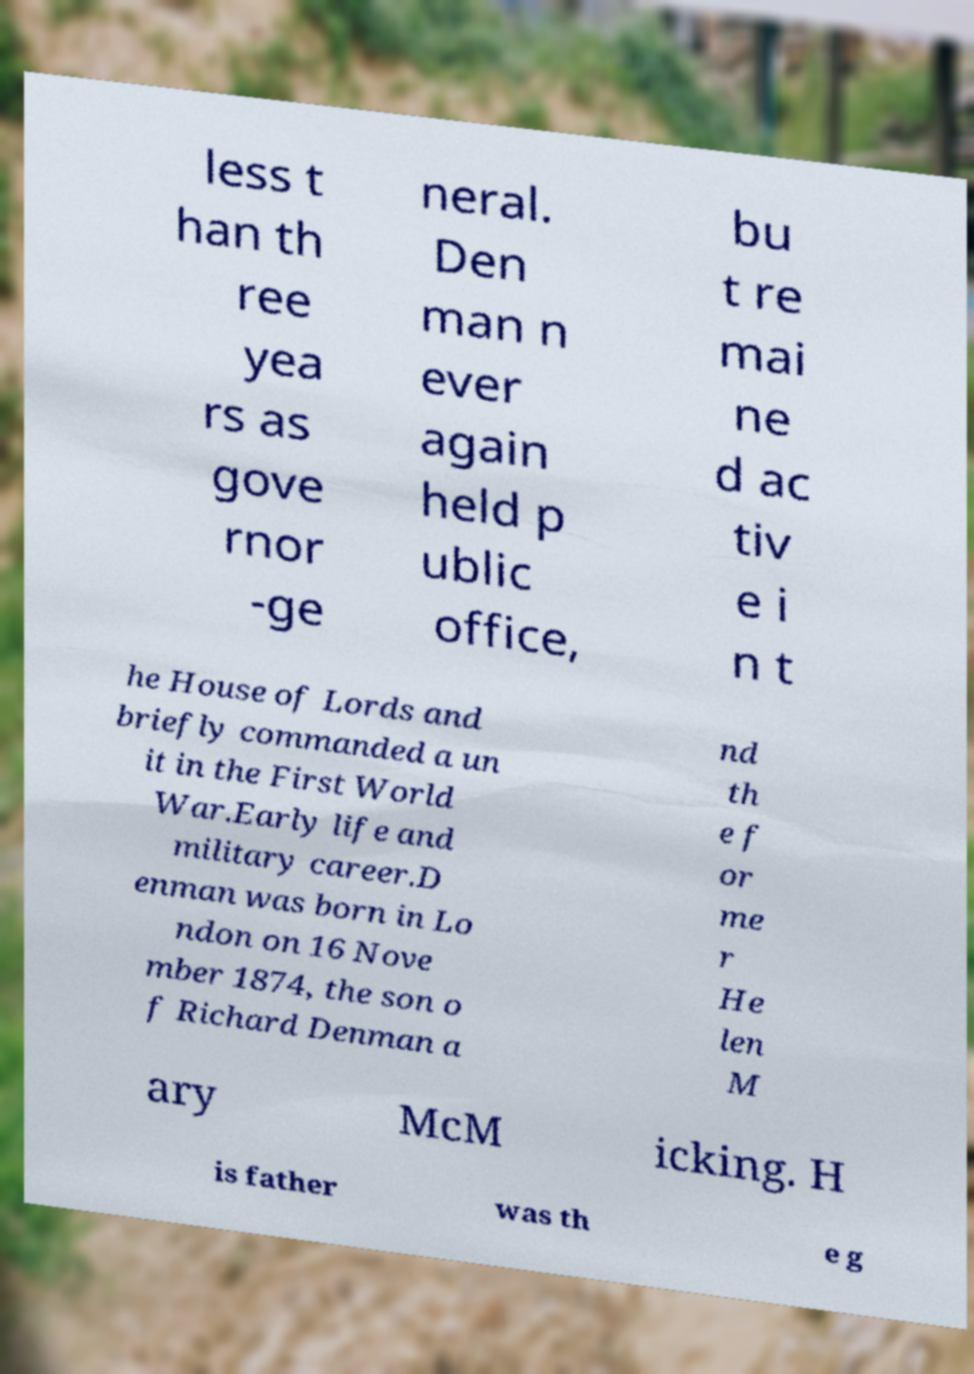Please identify and transcribe the text found in this image. less t han th ree yea rs as gove rnor -ge neral. Den man n ever again held p ublic office, bu t re mai ne d ac tiv e i n t he House of Lords and briefly commanded a un it in the First World War.Early life and military career.D enman was born in Lo ndon on 16 Nove mber 1874, the son o f Richard Denman a nd th e f or me r He len M ary McM icking. H is father was th e g 